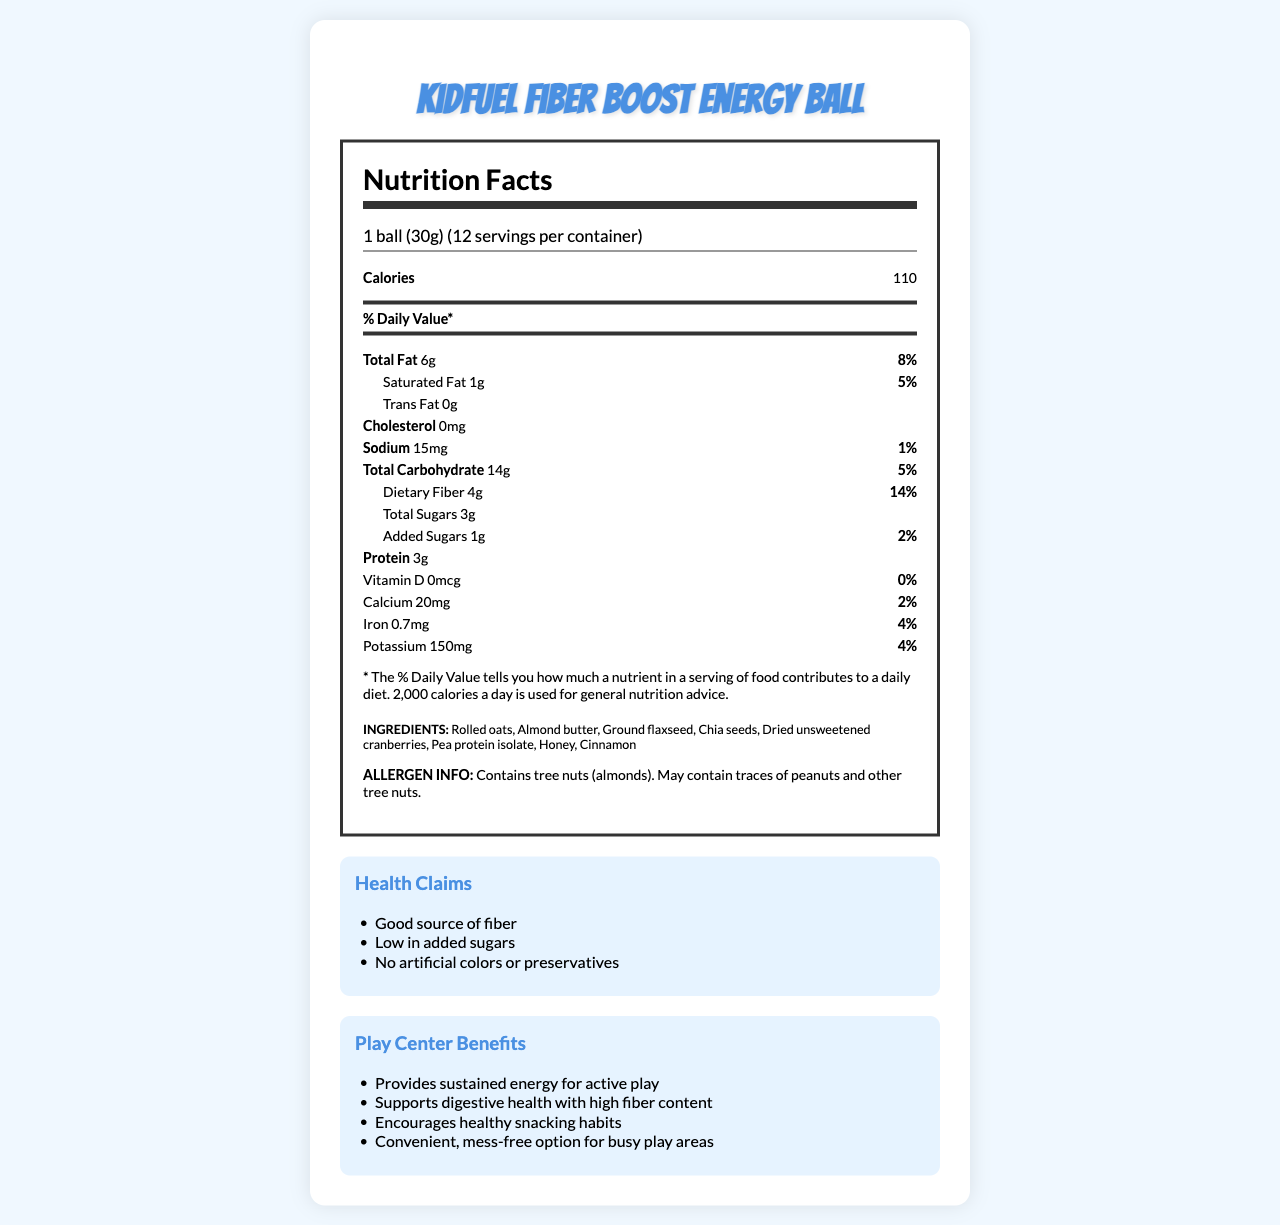What is the serving size of the KidFuel Fiber Boost Energy Ball? The serving size is clearly mentioned at the top of the nutrition facts label as "1 ball (30g)".
Answer: 1 ball (30g) How many servings are there per container? The number of servings per container is given as "12", right below the serving size information.
Answer: 12 How much dietary fiber is in one serving? The amount of dietary fiber per serving is listed as "4g" on the nutrition facts label.
Answer: 4g What percentage of the Daily Value is the dietary fiber? The percentage of the Daily Value for dietary fiber is given as "14%" on the nutrition label.
Answer: 14% What are the main allergens present in this product? The allergen information specifies that the product contains tree nuts (almonds) and may contain traces of peanuts and other tree nuts.
Answer: Tree nuts (almonds) How many calories are in one serving? The calorie count per serving is listed prominently on the nutrition facts label as "110".
Answer: 110 How much protein does one energy ball contain? The amount of protein per serving is specified as "3g" on the nutrition label.
Answer: 3g What is the total amount of sugars in a single serving? The total sugars per serving is listed as "3g" on the nutrition facts label.
Answer: 3g Which of the following is NOT an ingredient in the KidFuel Fiber Boost Energy Ball? A. Chia seeds B. Almond butter C. Chocolate chips The ingredients list includes chia seeds and almond butter but not chocolate chips.
Answer: C What is the shelf life of the KidFuel Fiber Boost Energy Ball? The additional information section mentions that the shelf life is "6 months when stored in a cool, dry place".
Answer: 6 months What is the recommended age for children to consume this energy ball? The additional information specifies that the energy ball is suitable for children 4 years and older.
Answer: Suitable for children 4 years and older Does the product contain any saturated fat? The nutrition label states that there is "1g" of saturated fat per serving.
Answer: Yes Summarize the main idea of the document. The summary covers all the sections of the document, including nutrition facts, ingredients, allergen info, health claims, play center benefits, and extra details like shelf life and recommended age, highlighting the overall purpose and benefits of the product.
Answer: The document provides the nutrition facts, ingredients, allergen information, health claims, play center benefits, and additional details for the KidFuel Fiber Boost Energy Ball. Designed for children, it is a low-sugar, high-fiber snack aimed at providing sustained energy, supporting digestive health, and encouraging healthy snacking habits. What is the amount of calcium in one serving, and what percentage of the Daily Value does it represent? The nutrition label lists "Calcium" as "20mg" and the corresponding Daily Value percentage as "2%".
Answer: 20mg and 2% Based on the nutrition label, can we determine the percentage of trans fat in the KidFuel Fiber Boost Energy Ball? While it states the trans fat amount is "0g", there is no percentage of the Daily Value provided for trans fat in the document.
Answer: Cannot be determined 